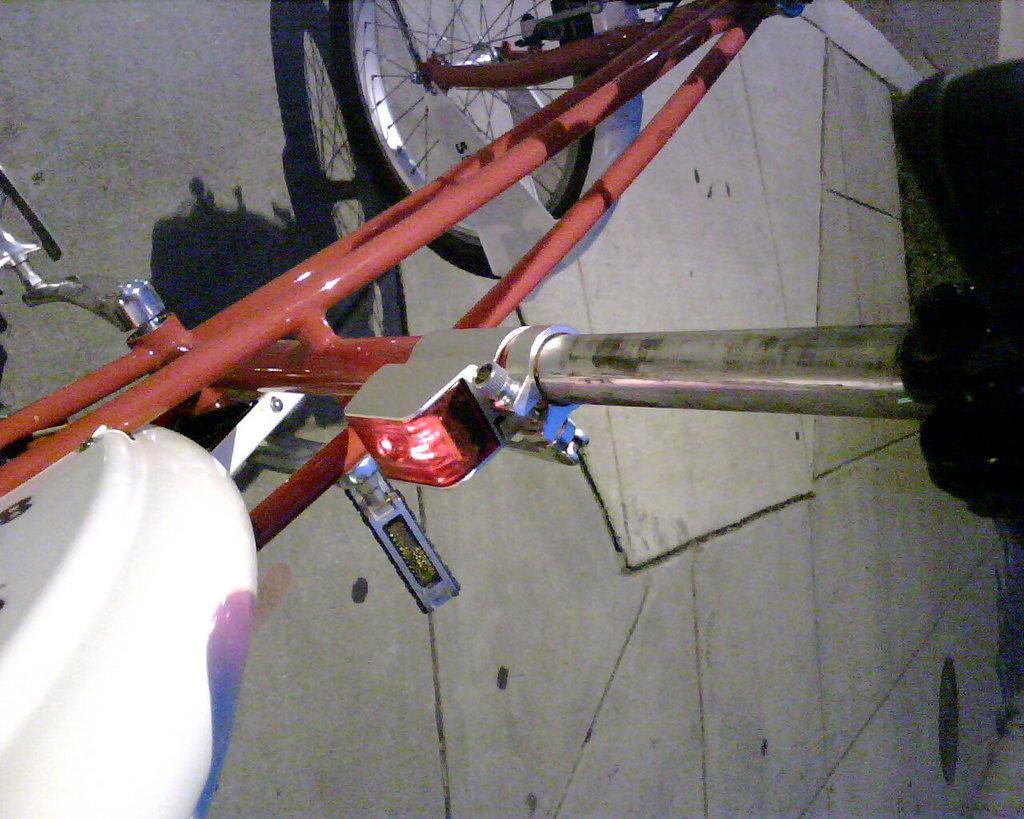How would you summarize this image in a sentence or two? In this picture I can see the bicycle on the floor. 